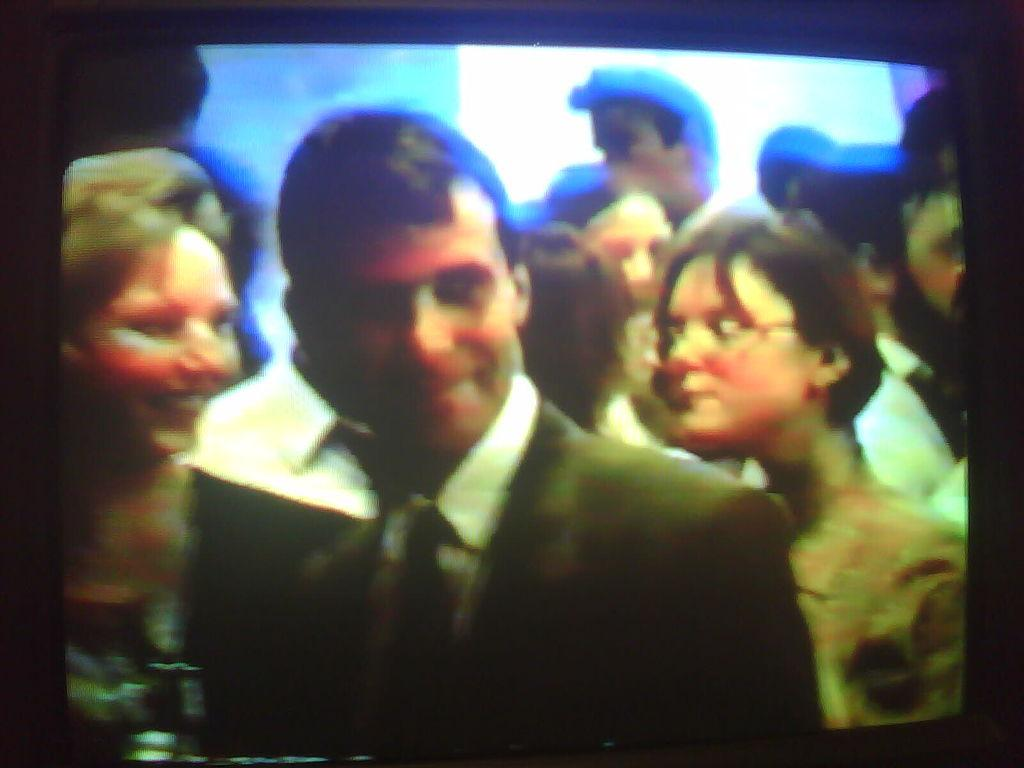What is located in the foreground of the image? There are people in the foreground of the image. Can you describe the background of the image? There is light visible in the background of the image. What type of basin is being used by the achiever in the image? There is no achiever or basin present in the image. 